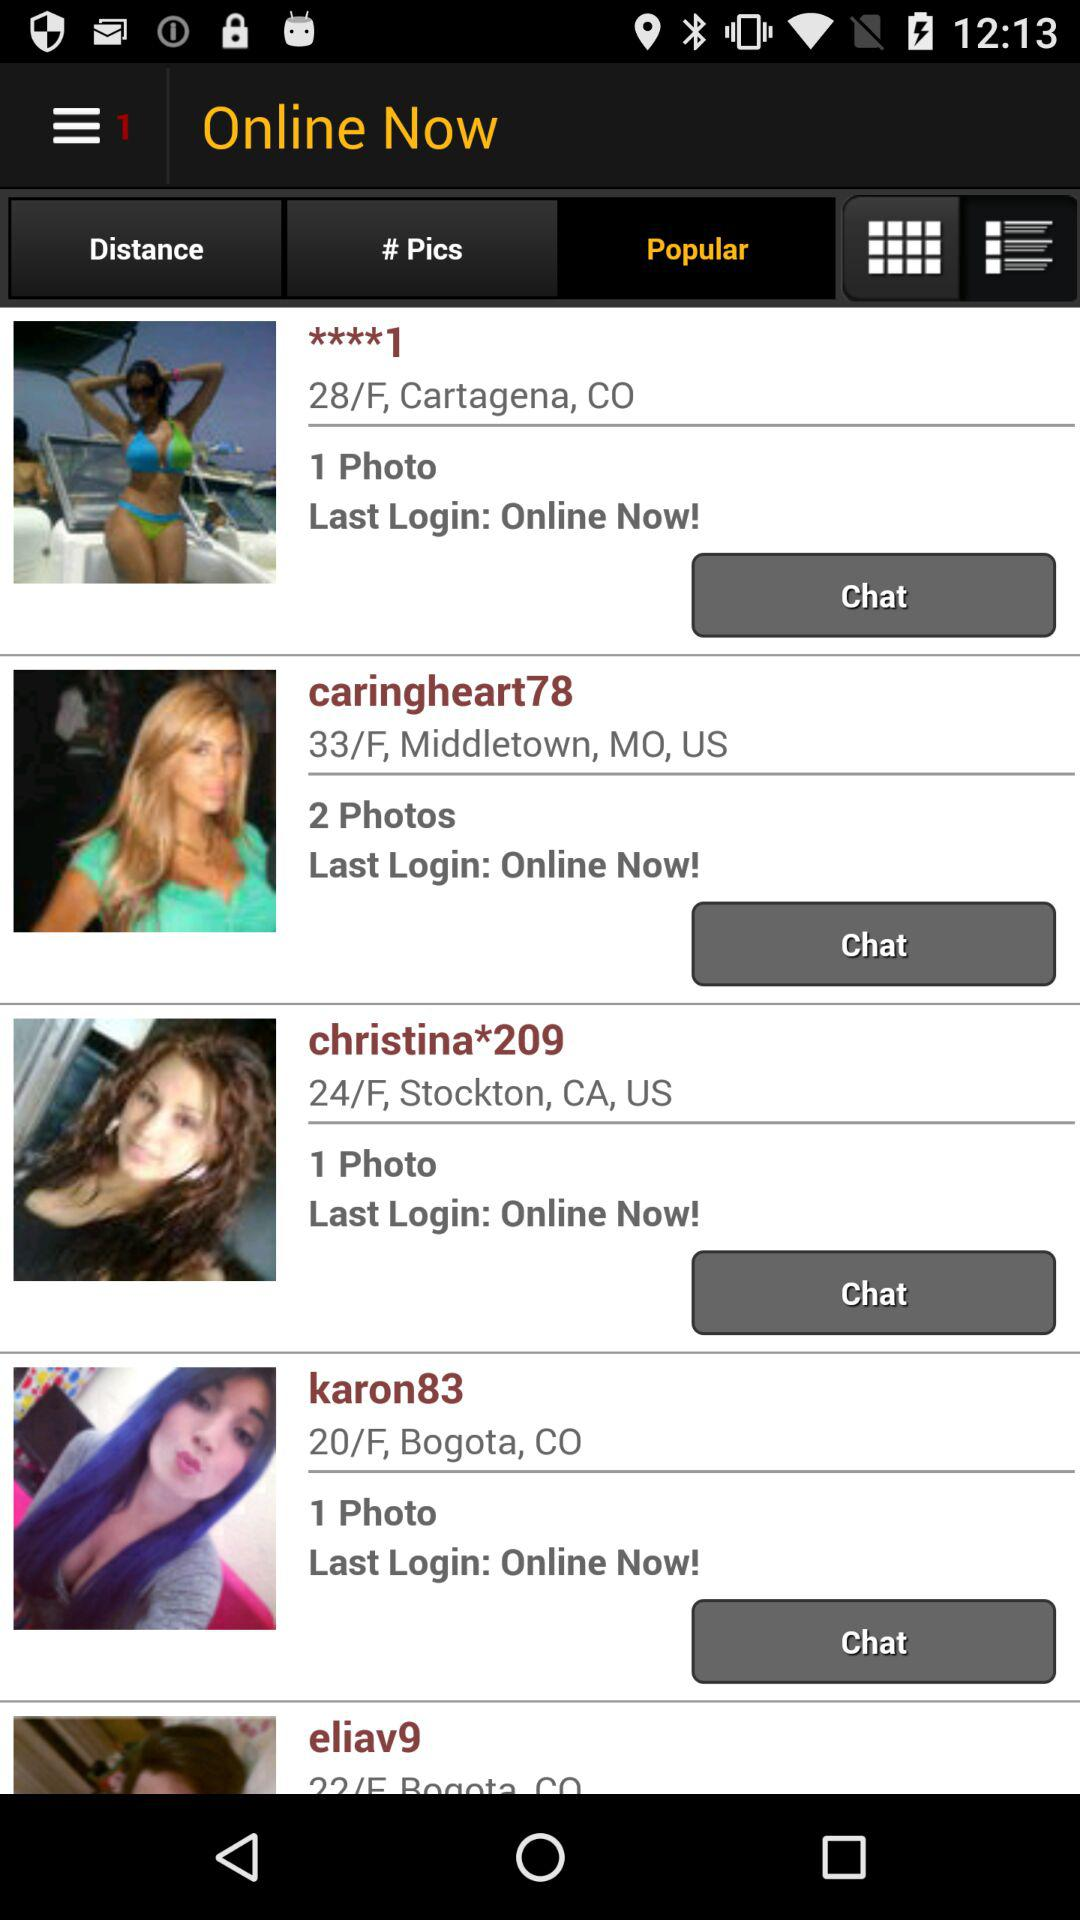What's the age of "karon83"? The age of "karon83" is 20. 